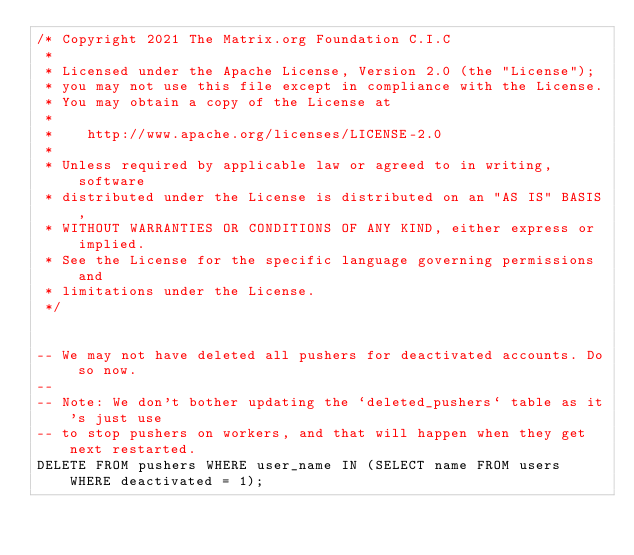Convert code to text. <code><loc_0><loc_0><loc_500><loc_500><_SQL_>/* Copyright 2021 The Matrix.org Foundation C.I.C
 *
 * Licensed under the Apache License, Version 2.0 (the "License");
 * you may not use this file except in compliance with the License.
 * You may obtain a copy of the License at
 *
 *    http://www.apache.org/licenses/LICENSE-2.0
 *
 * Unless required by applicable law or agreed to in writing, software
 * distributed under the License is distributed on an "AS IS" BASIS,
 * WITHOUT WARRANTIES OR CONDITIONS OF ANY KIND, either express or implied.
 * See the License for the specific language governing permissions and
 * limitations under the License.
 */


-- We may not have deleted all pushers for deactivated accounts. Do so now.
--
-- Note: We don't bother updating the `deleted_pushers` table as it's just use
-- to stop pushers on workers, and that will happen when they get next restarted.
DELETE FROM pushers WHERE user_name IN (SELECT name FROM users WHERE deactivated = 1);
</code> 